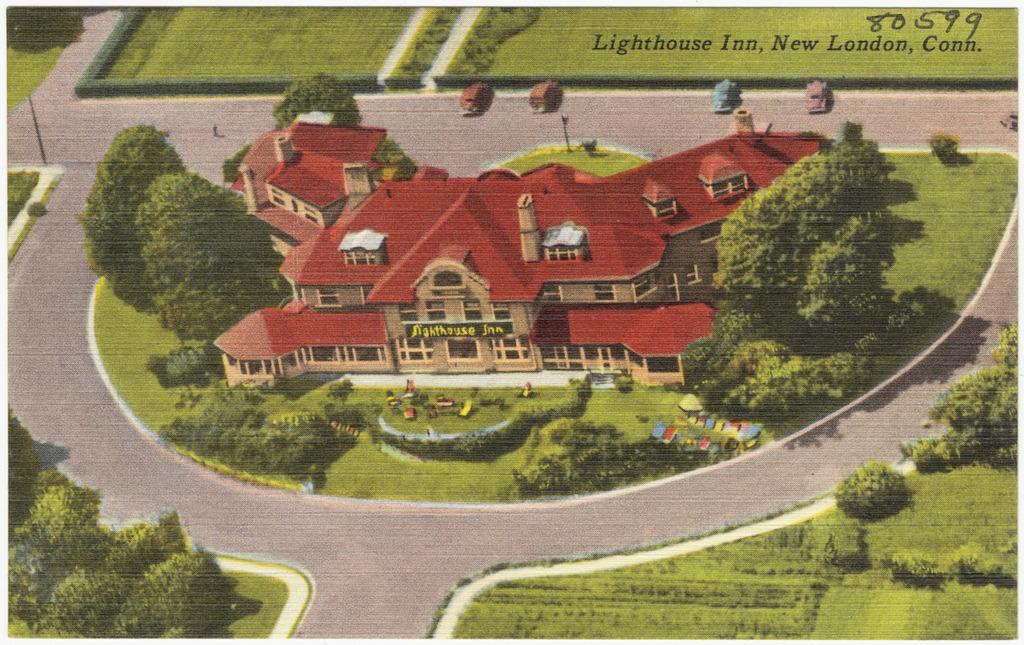What is the main subject of the image? The main subject of the image is a cover page. What is depicted on the cover page? The cover page contains a house. What other elements are present on the cover page? There are trees and shrubs on the cover page. What type of teeth can be seen on the cover page? There are no teeth depicted on the cover page; it features a house, trees, and shrubs. 